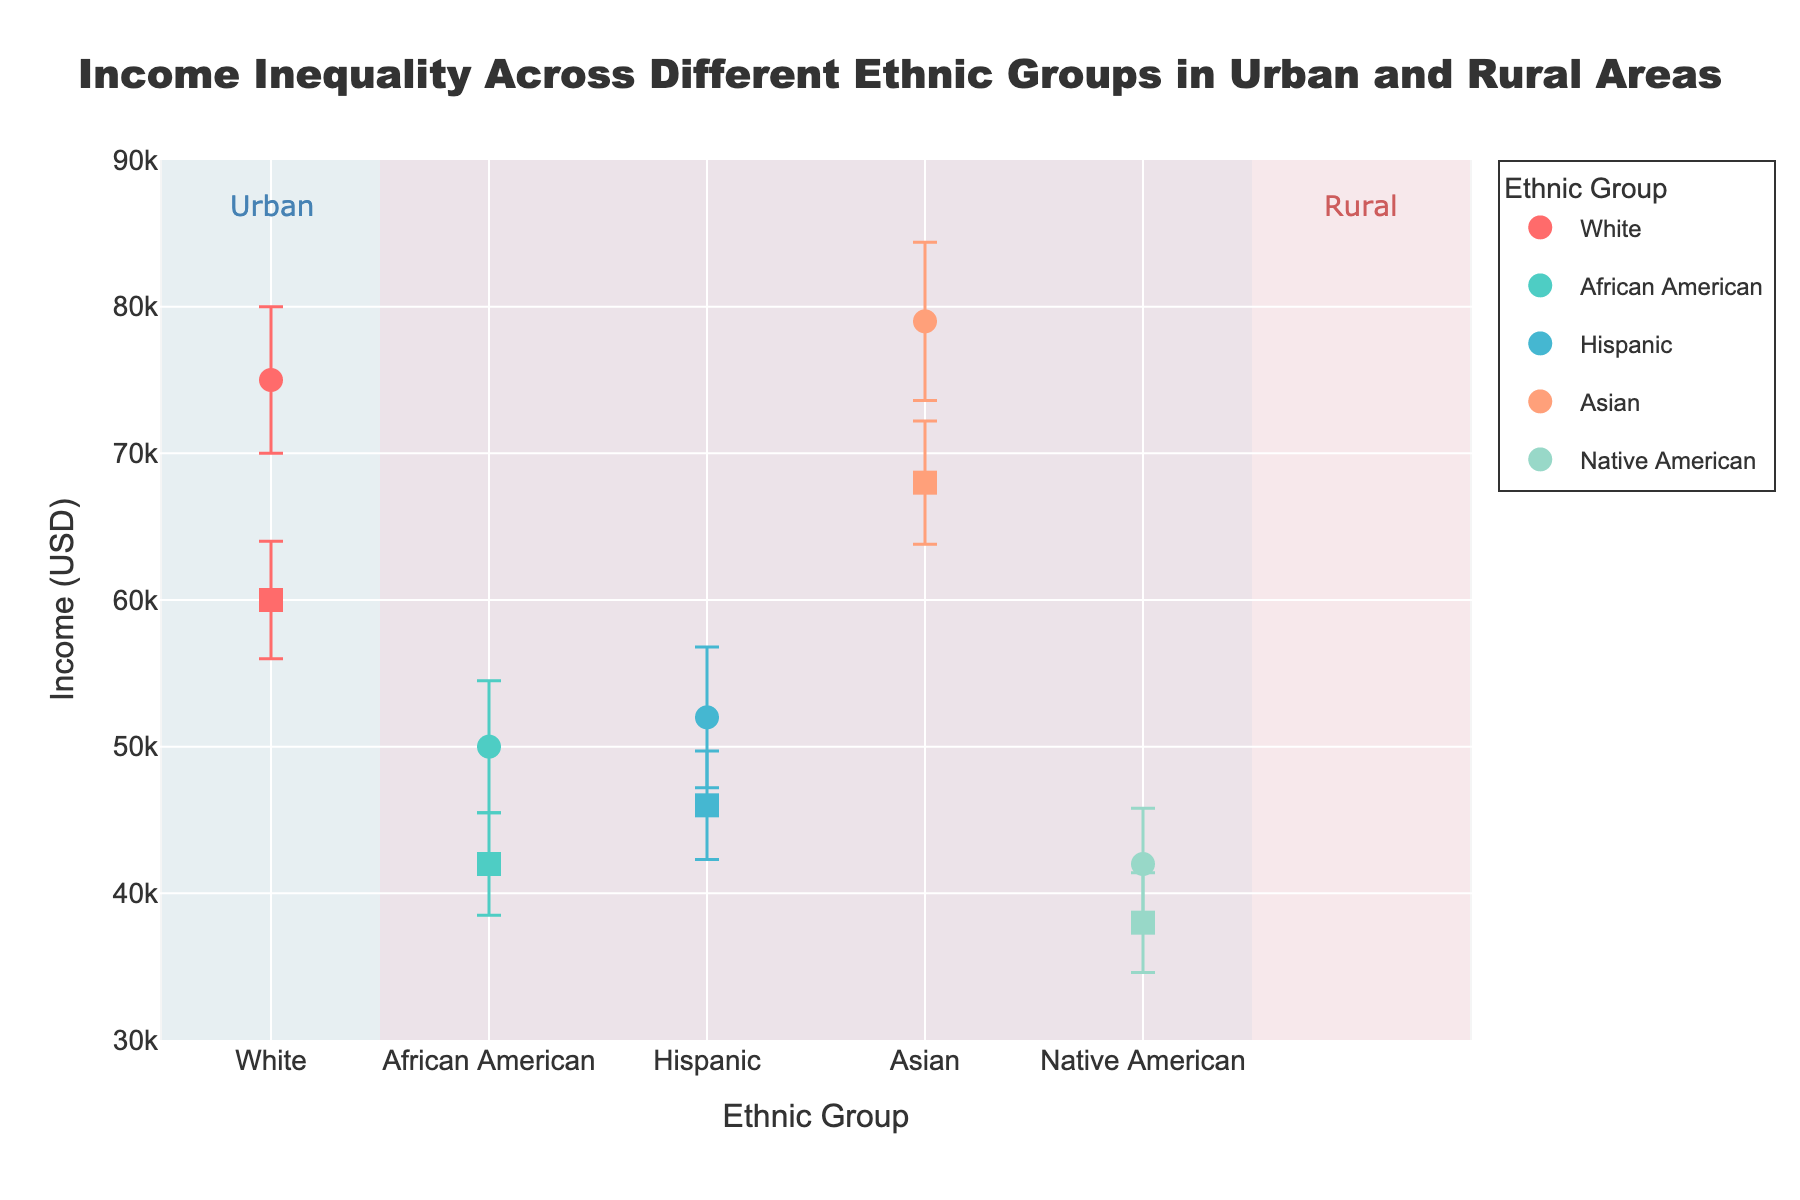what is the highest income mean among urban areas? The figure shows markers for each ethnic group with their respective income means. The highest income mean among urban areas is represented by the marker with the greatest y-value within the "Urban" annotation. This marker is for the Asian ethnic group.
Answer: 79000 what's the difference in income mean between the urban and rural areas for the hispanic group? Look at the markers representing the income means for the Hispanic group in both urban and rural areas. The urban income mean is 52000, and the rural income mean is 46000. Subtract the rural income from the urban income to find the difference.
Answer: 6000 which ethnic group has the smallest income mean in rural areas? Examine the markers representing rural areas (annotated "Rural"). Identify the marker with the lowest y-value, which corresponds to the Native American ethnic group.
Answer: Native American are the income means for urban areas generally higher than for rural areas? Compare markers for urban and rural areas for all ethnic groups. For most ethnic groups (White, African American, Hispanic, and Asian), the urban income mean is higher. Only the Native American group shows a small difference, with the urban income mean being slightly higher than the rural income mean.
Answer: Yes what's the income range of the urban african american group considering the error bars? Look at the income mean for the urban African American group and its error bars. The mean is 50000, and the standard deviation is 4500. To find the range, calculate 50000 ± 4500, which gives a range of 45500 to 54500.
Answer: 45500 to 54500 how does the income inequality of the native american group compare between urban and rural areas? Observe the error bars for the Native American group. Error bars indicate variability. The urban area's error bar extends from 38200 to 45800 (42000 ± 3800), and the rural area's error bar extends from 34600 to 41400 (38000 ± 3400). Comparatively, the variability (error bars) is slightly larger in urban areas.
Answer: Higher in Urban which area, urban or rural, shows greater income variation within the White group? Examine the error bars for the White ethnic group in both areas. Urban White has an error bar of 5000 and Rural White has an error bar of 4000. Therefore, urban areas show greater variation within the White group.
Answer: Urban what's the average income mean for the rural areas across all ethnic groups? Calculate the sum of the income means for all ethnic groups in rural areas: 60000 (White) + 42000 (African American) + 46000 (Hispanic) + 68000 (Asian) + 38000 (Native American) = 254000. Then divide by the number of ethnic groups (5): 254000 / 5 = 50800.
Answer: 50800 is there any ethnic group where the income mean for the rural area is higher than the urban area? Scan the markers for each ethnic group. In all cases, the income mean for rural areas is lower than for urban areas for every ethnic group represented in the figure.
Answer: No 